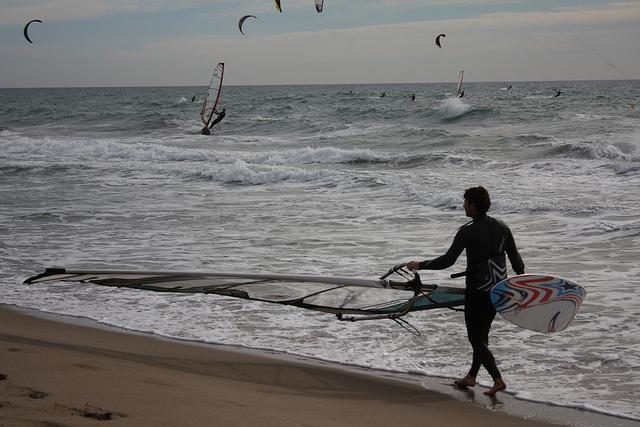How many birds are in the picture?
Give a very brief answer. 5. How many elephants are in this image?
Give a very brief answer. 0. 